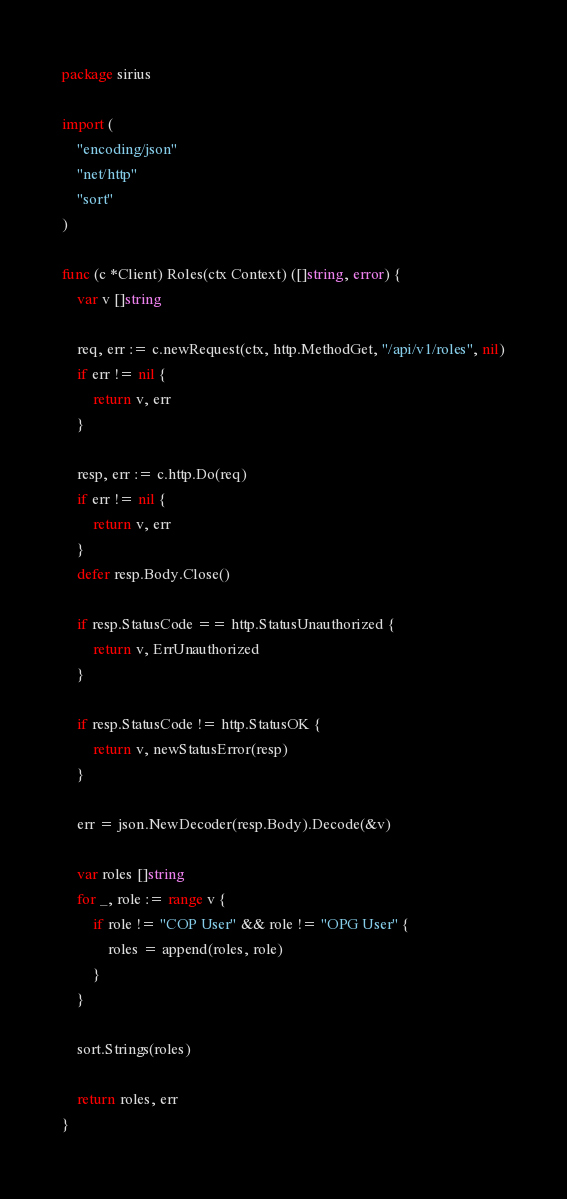<code> <loc_0><loc_0><loc_500><loc_500><_Go_>package sirius

import (
	"encoding/json"
	"net/http"
	"sort"
)

func (c *Client) Roles(ctx Context) ([]string, error) {
	var v []string

	req, err := c.newRequest(ctx, http.MethodGet, "/api/v1/roles", nil)
	if err != nil {
		return v, err
	}

	resp, err := c.http.Do(req)
	if err != nil {
		return v, err
	}
	defer resp.Body.Close()

	if resp.StatusCode == http.StatusUnauthorized {
		return v, ErrUnauthorized
	}

	if resp.StatusCode != http.StatusOK {
		return v, newStatusError(resp)
	}

	err = json.NewDecoder(resp.Body).Decode(&v)

	var roles []string
	for _, role := range v {
		if role != "COP User" && role != "OPG User" {
			roles = append(roles, role)
		}
	}

	sort.Strings(roles)

	return roles, err
}
</code> 